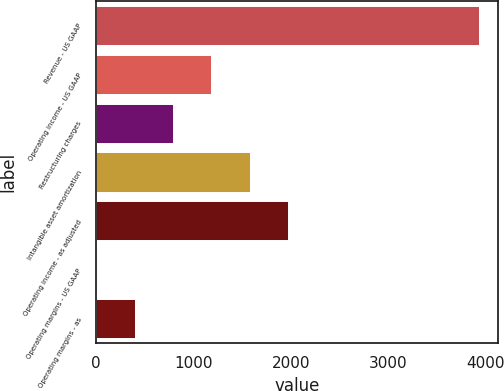<chart> <loc_0><loc_0><loc_500><loc_500><bar_chart><fcel>Revenue - US GAAP<fcel>Operating income - US GAAP<fcel>Restructuring charges<fcel>Intangible asset amortization<fcel>Operating income - as adjusted<fcel>Operating margins - US GAAP<fcel>Operating margins - as<nl><fcel>3925<fcel>1182.68<fcel>790.92<fcel>1574.44<fcel>1966.2<fcel>7.4<fcel>399.16<nl></chart> 